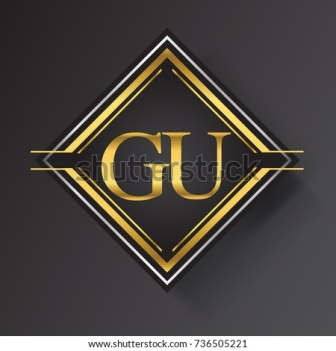Imagine if this emblem were part of a historical artifact. What could its story be? If this emblem were part of a historical artifact, it might tell the story of an ancient, yet advanced civilization, known for its wealth and cultural achievements. The emblem could have been part of a royal insignia or a treasure, symbolizing authority and power. It might have adorned the armor of a noble warrior or been the mark of an elite guild. Stories of this emblem might have been passed down through generations, each time embellishing its significance and the legendary status of 'GU'. Wow, that’s fascinating! Can you delve deeper into what sounds like a fictional narrative around this emblem? In a bygone era, in the heart of a sprawling empire, the emblem of 'GU' was known far and wide. The 'GU' Guild was famed for their unparalleled crafts in goldsmithing and gemology. They created unparalleled works of art and crafted the most coveted treasures. Legend has it that the leader of the GU Guild possessed a mystical diamond, believed to hold the key to unmatched knowledge and prosperity. The emblem, gilded with their famed gold, was a beacon of their guild's power and influence, and it graced the halls of the empire's grandest structures. Decorated on the emperor’s throne and integrated into ceremonial garb, it signified power, wisdom, and an endless pursuit of excellence. 